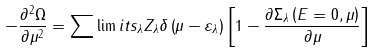Convert formula to latex. <formula><loc_0><loc_0><loc_500><loc_500>- \frac { \partial ^ { 2 } \Omega } { \partial \mu ^ { 2 } } = \sum \lim i t s _ { \lambda } Z _ { \lambda } \delta \left ( \mu - \varepsilon _ { \lambda } \right ) \left [ 1 - \frac { \partial \Sigma _ { \lambda } \left ( E = 0 , \mu \right ) } { \partial \mu } \right ]</formula> 